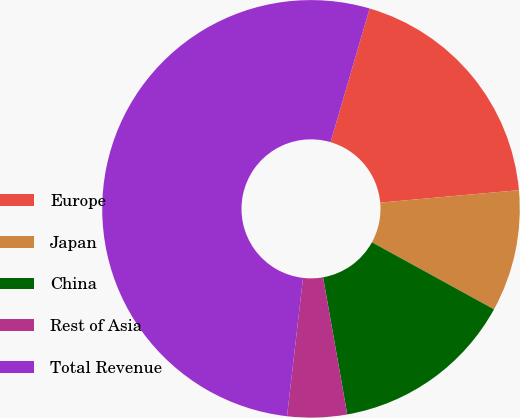Convert chart to OTSL. <chart><loc_0><loc_0><loc_500><loc_500><pie_chart><fcel>Europe<fcel>Japan<fcel>China<fcel>Rest of Asia<fcel>Total Revenue<nl><fcel>19.04%<fcel>9.42%<fcel>14.23%<fcel>4.61%<fcel>52.71%<nl></chart> 